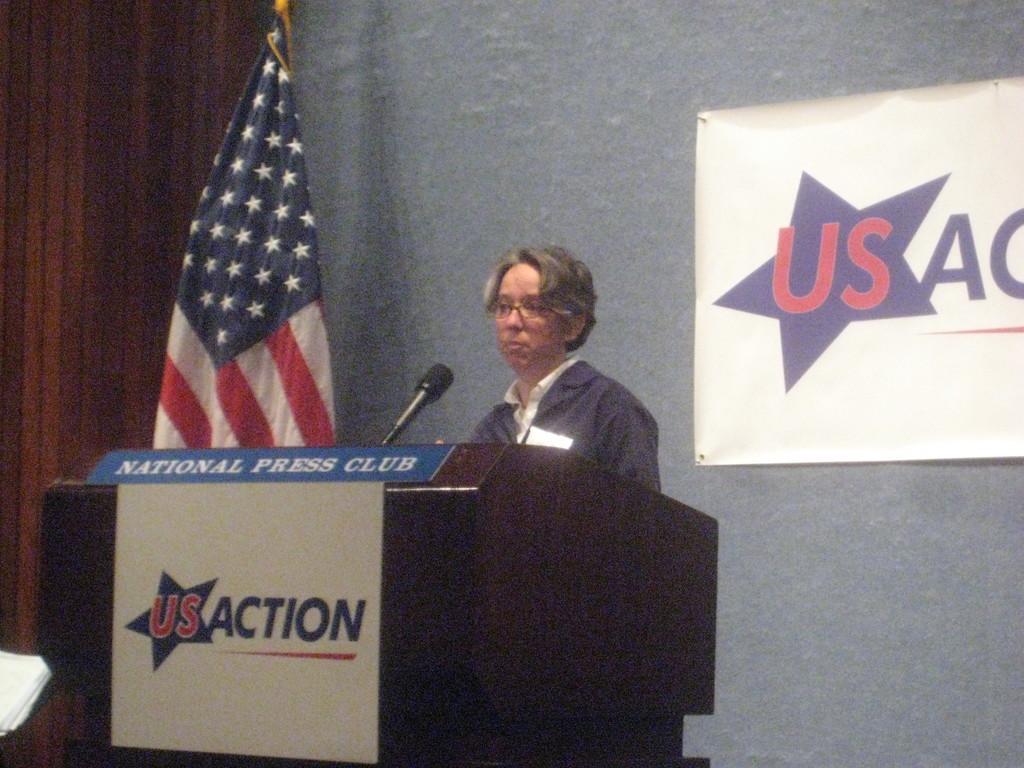Could you give a brief overview of what you see in this image? In this picture I can observe a person standing in front of a brown color podium. I can observe a mic on this podium. On the left side there is a national flag. I can observe a poster fixed to the wall on the right side. 